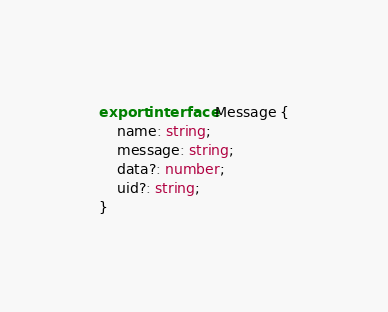Convert code to text. <code><loc_0><loc_0><loc_500><loc_500><_TypeScript_>export interface Message {
    name: string;
    message: string;
    data?: number;
    uid?: string;
}
</code> 